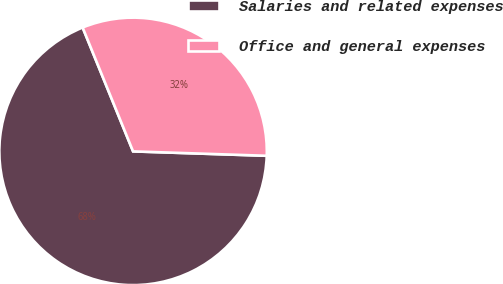Convert chart to OTSL. <chart><loc_0><loc_0><loc_500><loc_500><pie_chart><fcel>Salaries and related expenses<fcel>Office and general expenses<nl><fcel>68.32%<fcel>31.68%<nl></chart> 